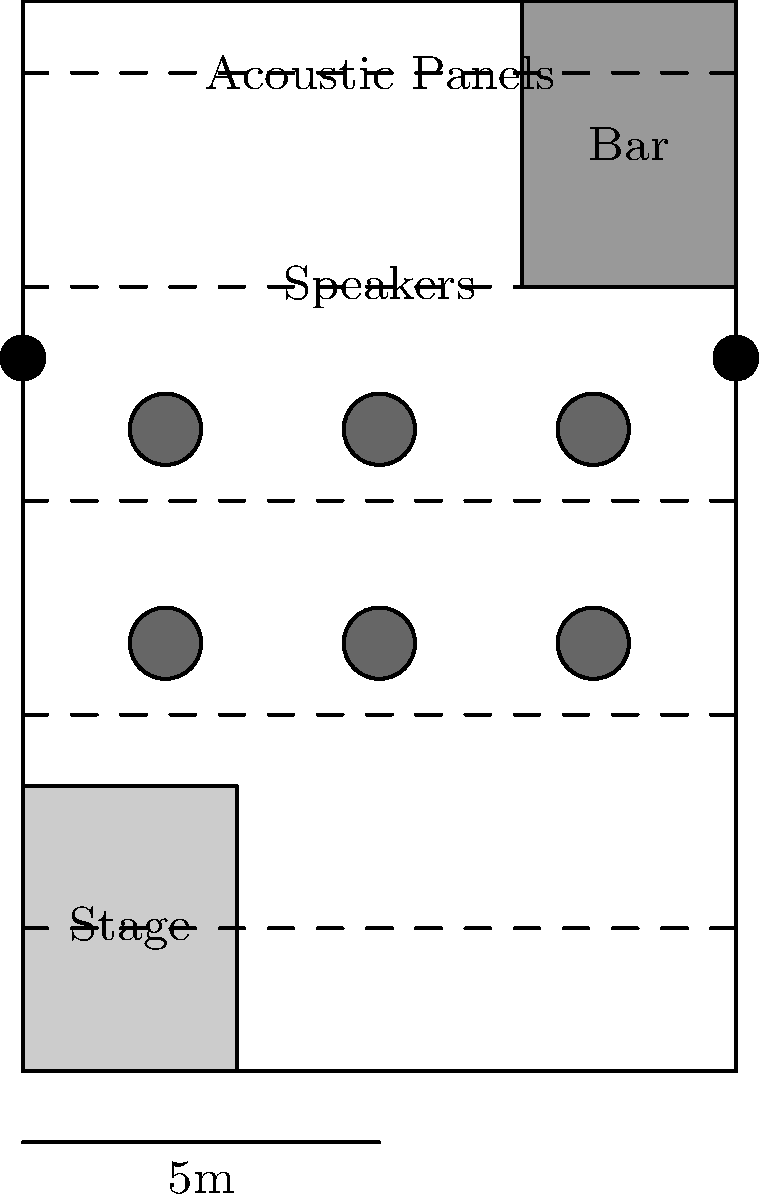Based on the floor plan of the jazz club shown above, which acoustic design element is most crucial for ensuring optimal sound dispersion throughout the venue, and why is its placement important for the audience experience? To answer this question, let's analyze the acoustic design elements in the floor plan:

1. Acoustic Panels: These are represented by dashed lines across the ceiling of the club. They are crucial for controlling reverberation and echo in the space.

2. Speakers: Two speakers are placed at the back of the room, opposite the stage.

3. Room Shape: The room is rectangular, which can create standing waves and uneven sound distribution.

4. Stage Placement: The stage is located at one end of the room, which affects sound projection.

Among these elements, the acoustic panels are the most crucial for ensuring optimal sound dispersion throughout the venue. Here's why:

1. Sound Absorption: Acoustic panels absorb excess sound energy, reducing reverberation and echo. This is especially important in a jazz club where clarity of sound is essential.

2. Even Distribution: The panels are placed at regular intervals across the ceiling, ensuring that sound absorption is consistent throughout the space.

3. Customizable: The placement of these panels can be adjusted to address specific acoustic issues in different areas of the club.

4. Audience Experience: By reducing unwanted reflections and controlling reverberation, acoustic panels help maintain the integrity of the music, allowing audience members to hear the nuances of jazz performances clearly, regardless of their location in the club.

5. Complementary to Other Elements: While speakers are important for sound reinforcement, and room shape affects sound distribution, acoustic panels work in conjunction with these elements to fine-tune the overall acoustic environment.

The placement of acoustic panels across the entire ceiling is important because it ensures that sound quality is consistent throughout the venue. This arrangement helps to:

- Minimize dead spots or areas with excessive echo
- Maintain a balanced sound field for all audience members
- Preserve the intimate atmosphere characteristic of jazz clubs

In conclusion, while all acoustic design elements play a role, the acoustic panels are the most crucial for ensuring optimal sound dispersion due to their ability to control reverberation, provide even sound absorption, and enhance the overall listening experience for the audience.
Answer: Acoustic panels; their ceiling-wide placement ensures consistent sound quality throughout the venue. 